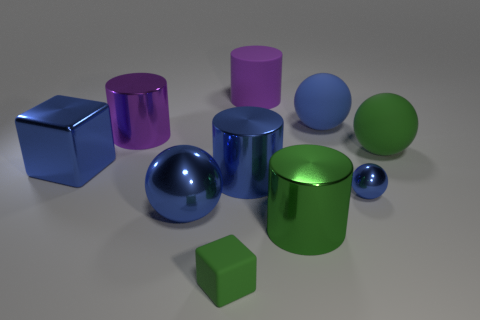Subtract all purple cylinders. How many blue spheres are left? 3 Subtract all cubes. How many objects are left? 8 Subtract 0 brown balls. How many objects are left? 10 Subtract all blue objects. Subtract all tiny brown rubber things. How many objects are left? 5 Add 1 green blocks. How many green blocks are left? 2 Add 7 large purple metallic cylinders. How many large purple metallic cylinders exist? 8 